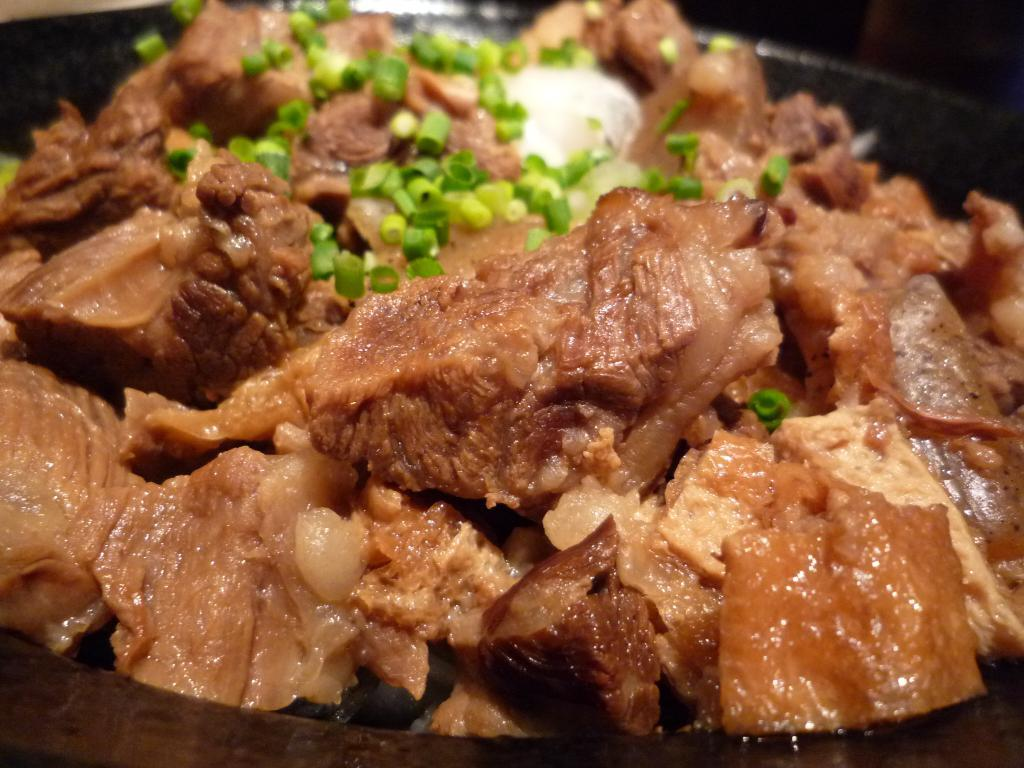What type of food can be seen in the image? There is a food item made of meat in the image. What specific ingredient is present in the food item? The food item contains spring onions. Are there any other ingredients in the food item? Yes, the food item contains other ingredients besides meat and spring onions. How is the food item presented in the image? The food item is in a bowl. What type of coach is present in the image? There is no coach present in the image; it features a food item made of meat. Can you tell me how many knees are visible in the image? There are no knees visible in the image; it features a food item made of meat. 